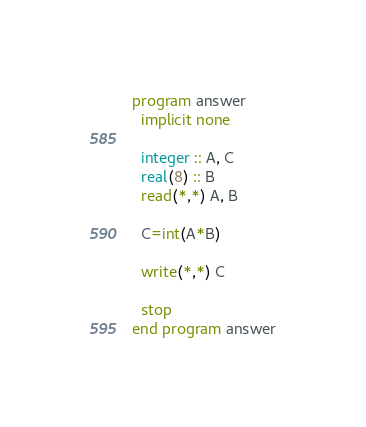Convert code to text. <code><loc_0><loc_0><loc_500><loc_500><_FORTRAN_>program answer
  implicit none

  integer :: A, C
  real(8) :: B
  read(*,*) A, B

  C=int(A*B)

  write(*,*) C

  stop
end program answer

</code> 